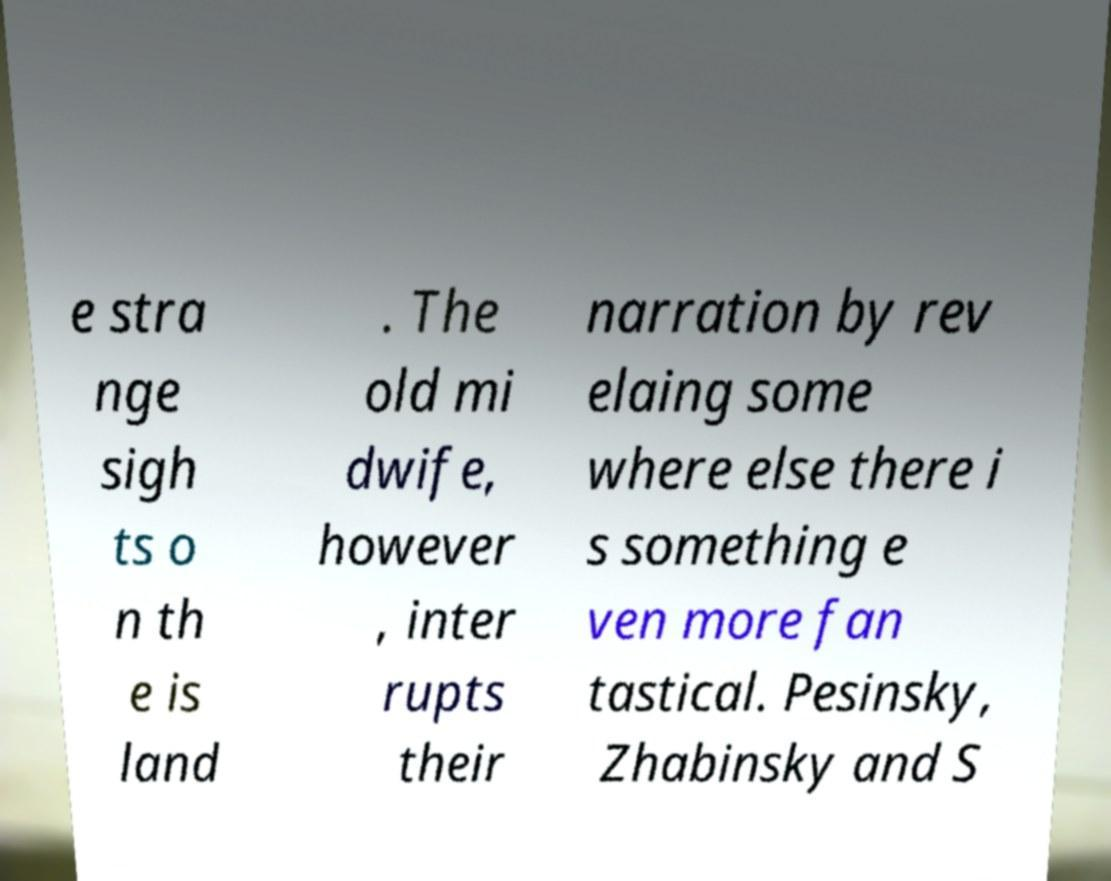There's text embedded in this image that I need extracted. Can you transcribe it verbatim? e stra nge sigh ts o n th e is land . The old mi dwife, however , inter rupts their narration by rev elaing some where else there i s something e ven more fan tastical. Pesinsky, Zhabinsky and S 